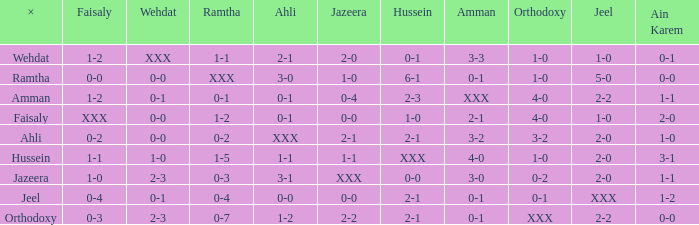What is ramtha when jeel is 1-0 and hussein is 1-0? 1-2. 